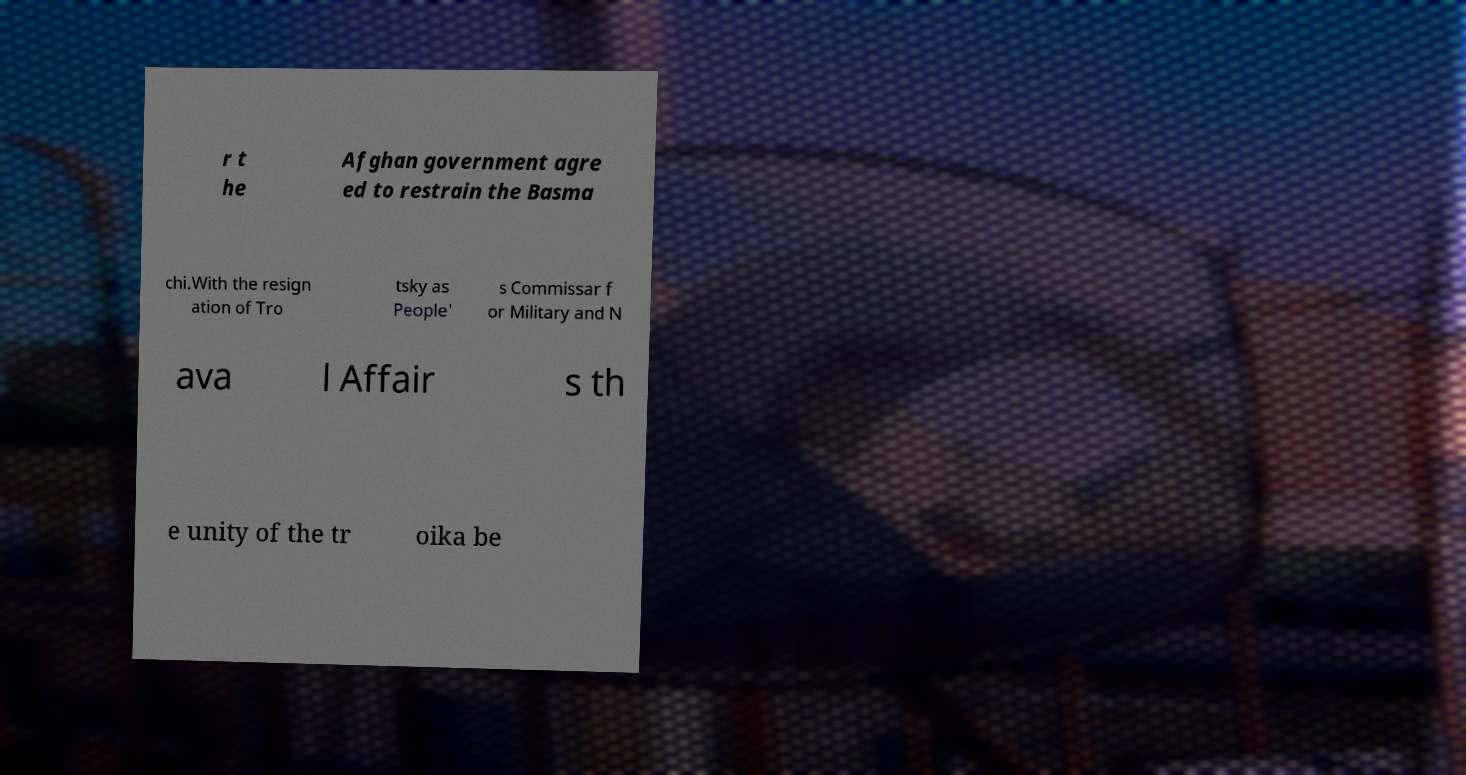Please identify and transcribe the text found in this image. r t he Afghan government agre ed to restrain the Basma chi.With the resign ation of Tro tsky as People' s Commissar f or Military and N ava l Affair s th e unity of the tr oika be 